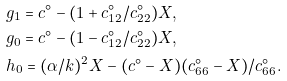Convert formula to latex. <formula><loc_0><loc_0><loc_500><loc_500>& g _ { 1 } = c ^ { \circ } - ( 1 + c ^ { \circ } _ { 1 2 } / c ^ { \circ } _ { 2 2 } ) X , \\ & g _ { 0 } = c ^ { \circ } - ( 1 - c ^ { \circ } _ { 1 2 } / c ^ { \circ } _ { 2 2 } ) X , \\ & h _ { 0 } = ( \alpha / k ) ^ { 2 } X - ( c ^ { \circ } - X ) ( c ^ { \circ } _ { 6 6 } - X ) / c ^ { \circ } _ { 6 6 } .</formula> 